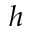<formula> <loc_0><loc_0><loc_500><loc_500>h</formula> 